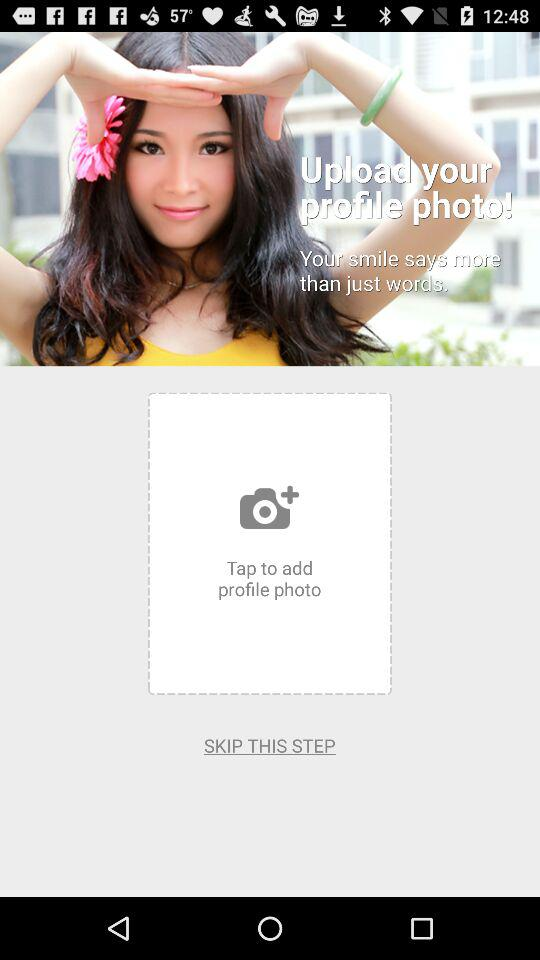How many steps are there in the process?
Answer the question using a single word or phrase. 2 